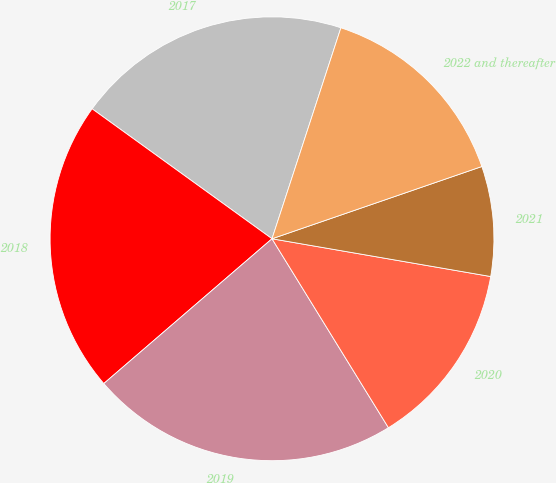Convert chart. <chart><loc_0><loc_0><loc_500><loc_500><pie_chart><fcel>2017<fcel>2018<fcel>2019<fcel>2020<fcel>2021<fcel>2022 and thereafter<nl><fcel>20.07%<fcel>21.27%<fcel>22.48%<fcel>13.49%<fcel>8.0%<fcel>14.7%<nl></chart> 